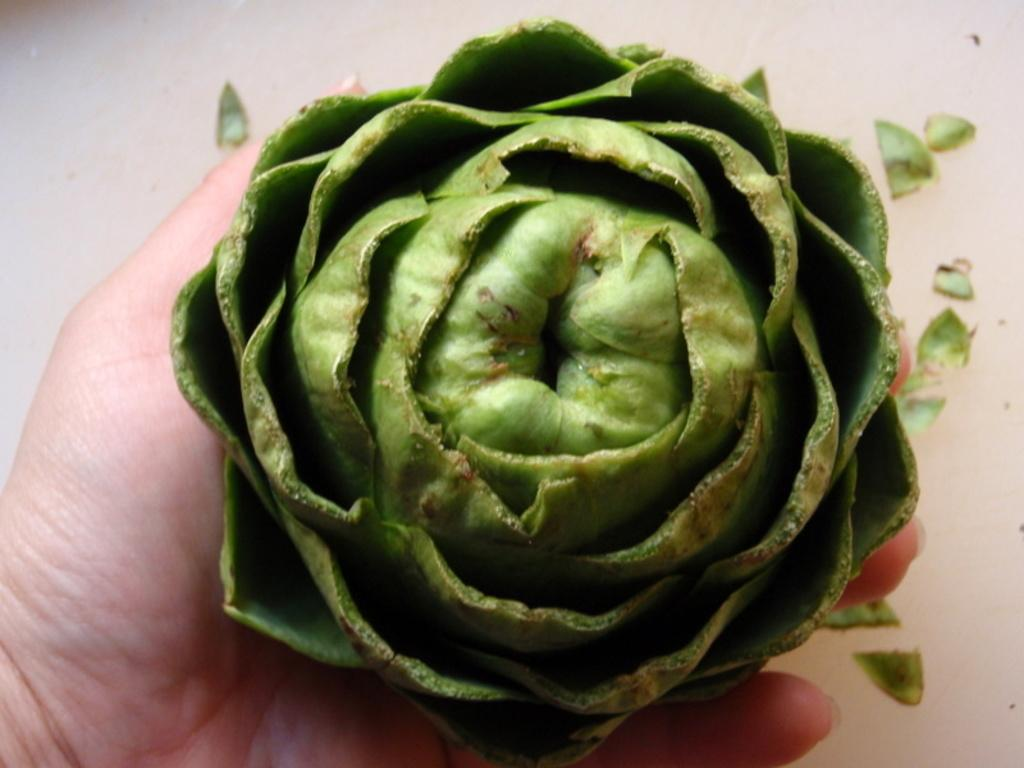What part of a person is visible in the image? There is a hand of a person in the image. What is on the hand in the image? There is a green color thing on the hand. What can be seen in the background of the image? There are additional green color things visible in the background of the image. What decisions is the committee making in the image? There is no committee present in the image, so no decisions are being made. What type of trade is being conducted in the image? There is no trade being conducted in the image. 